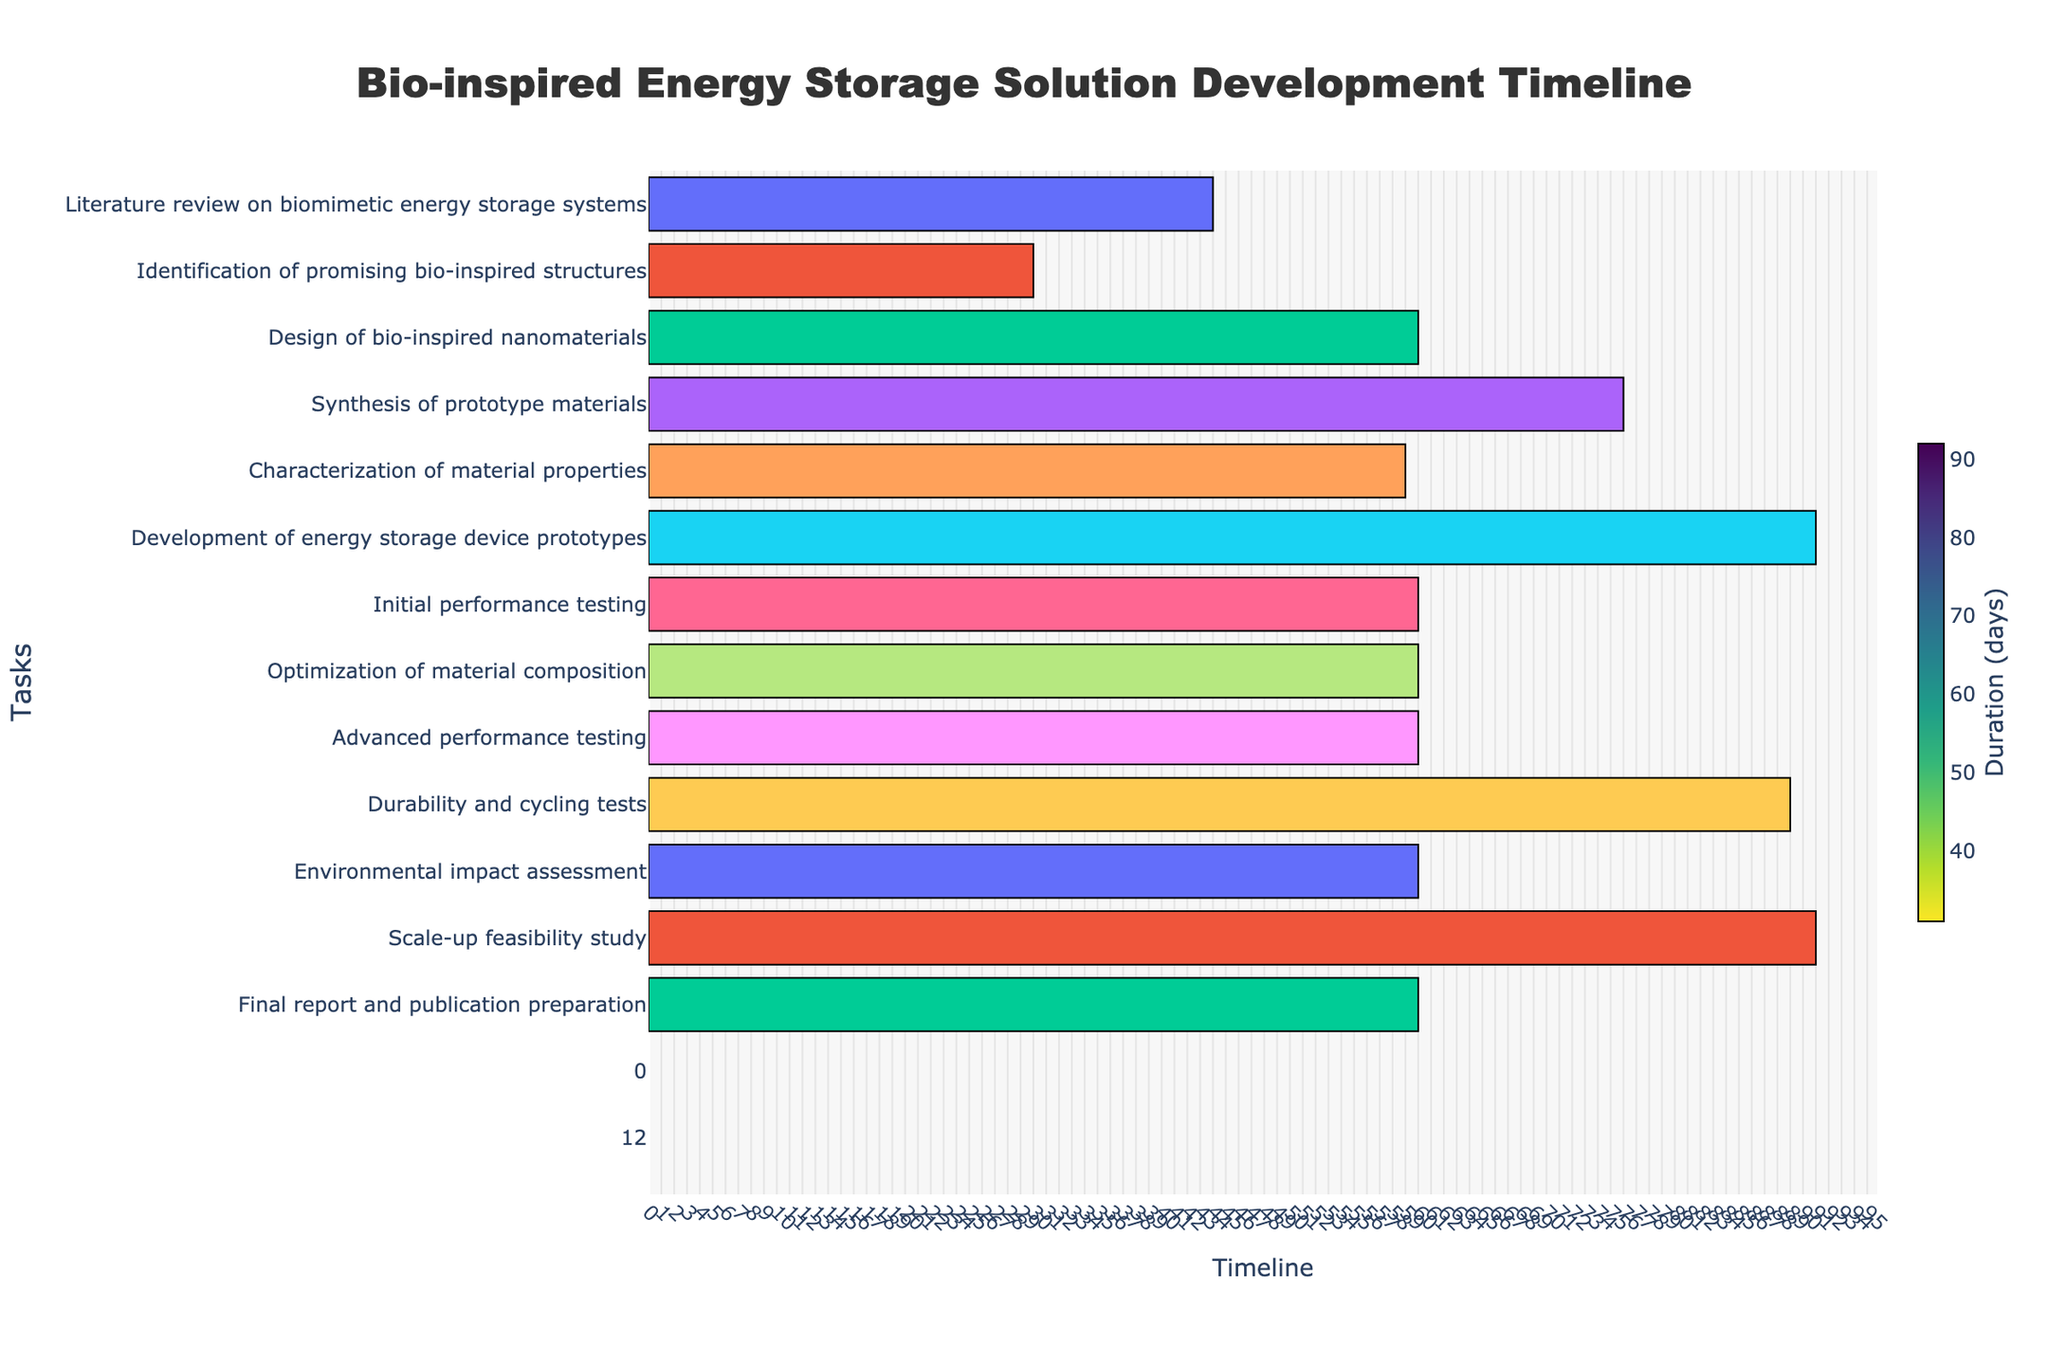What is the title of the Gantt chart? The title of the Gantt chart is located at the top center of the figure and provides the primary heading for the chart.
Answer: Bio-inspired Energy Storage Solution Development Timeline Which task has the longest duration? To find the task with the longest duration, look for the task with the longest bar on the chart.
Answer: Development of energy storage device prototypes When does the 'Synthesis of prototype materials' task begin and end? Look for the bar corresponding to 'Synthesis of prototype materials' in the chart and check the start and end dates provided in the hover information.
Answer: 2023-10-16 to 2023-12-31 How many days does the 'Literature review on biomimetic energy storage systems' task take to complete? Identify the 'Literature review on biomimetic energy storage systems' task in the chart and check the hover information for its duration.
Answer: 45 days What's the combined duration of 'Initial performance testing' and 'Advanced performance testing'? Find the durations of 'Initial performance testing' (61 days) and 'Advanced performance testing' (61 days) in the chart's hover information, then sum them up.
Answer: 122 days Which tasks overlap with 'Optimization of material composition'? Observe the bar representing 'Optimization of material composition' and identify the bars that visually overlap with its timeline.
Answer: Initial performance testing and Advanced performance testing How does the duration of 'Scale-up feasibility study' compare to the 'Development of energy storage device prototypes'? Locate both tasks in the chart, compare the lengths of the bars to note the relative duration.
Answer: They have the same duration What are the start and end dates of the entire project? The start and end dates of the project are represented by the project's earliest start date and latest end date in the Gantt chart.
Answer: 2023-06-01 to 2025-09-30 What is the average duration of tasks in the development phase (spanning from 'Development of energy storage device prototypes' to 'Scale-up feasibility study')? Sum the durations of all tasks within the specified phase and divide by the number of tasks in that phase.
Answer: 81 days 